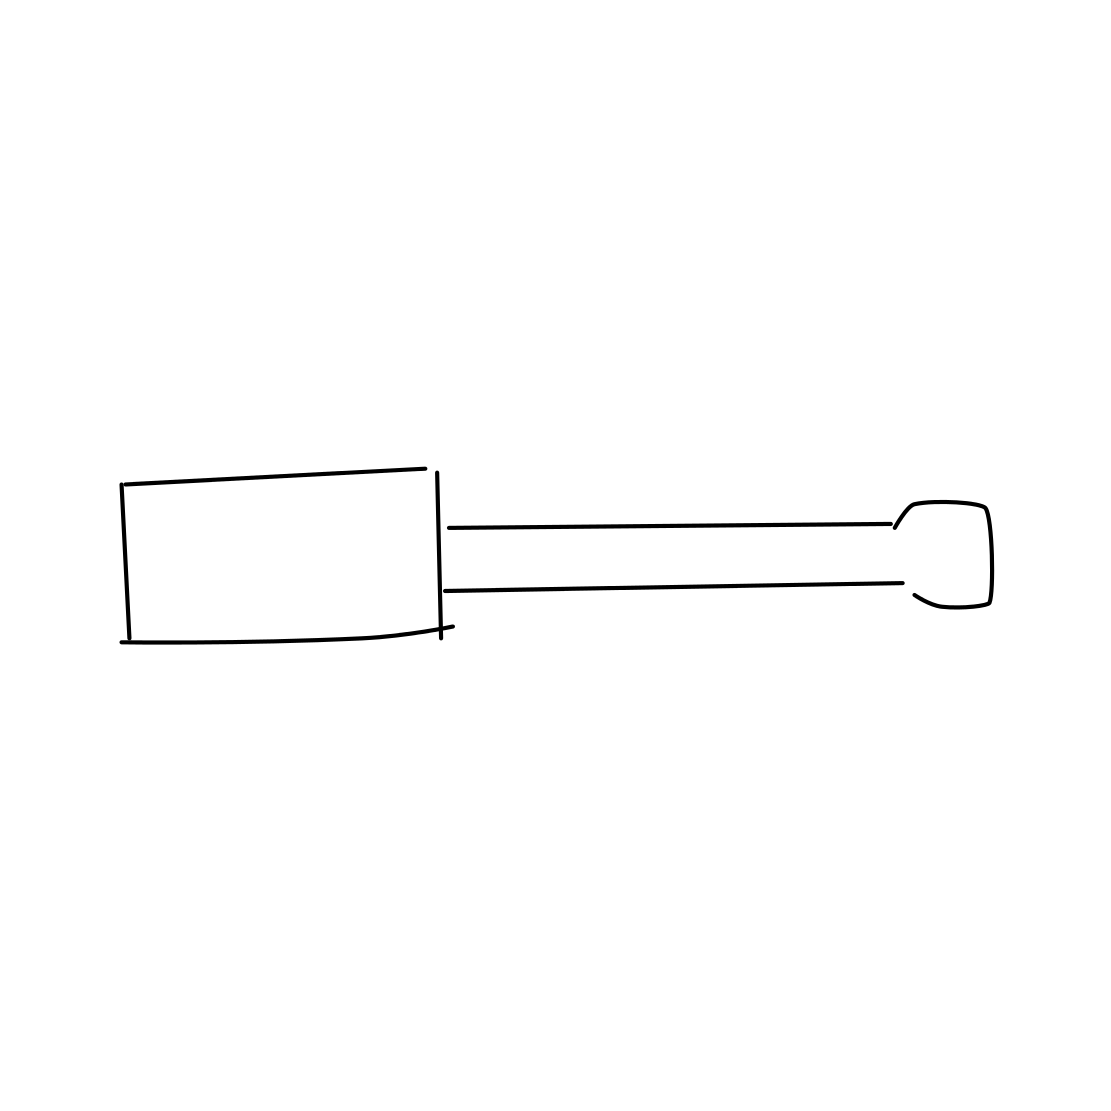What type of screwdriver is shown in this image? Based on the image, the screwdriver appears to be a flathead with a single slot on the tip suitable for screws with a linear notch. 